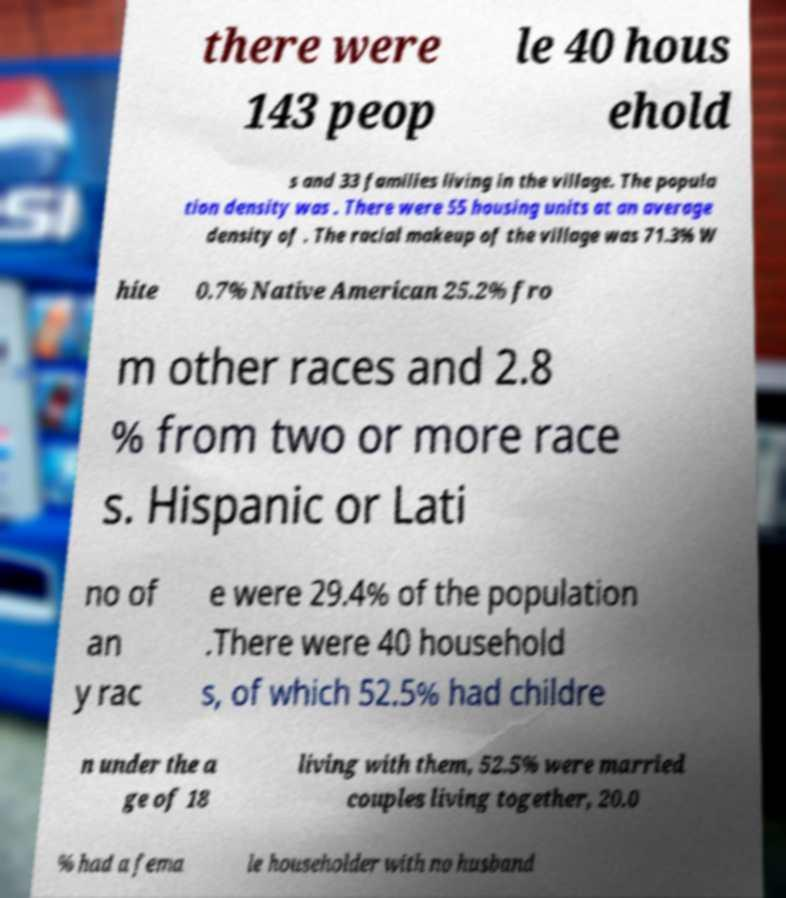Could you assist in decoding the text presented in this image and type it out clearly? there were 143 peop le 40 hous ehold s and 33 families living in the village. The popula tion density was . There were 55 housing units at an average density of . The racial makeup of the village was 71.3% W hite 0.7% Native American 25.2% fro m other races and 2.8 % from two or more race s. Hispanic or Lati no of an y rac e were 29.4% of the population .There were 40 household s, of which 52.5% had childre n under the a ge of 18 living with them, 52.5% were married couples living together, 20.0 % had a fema le householder with no husband 